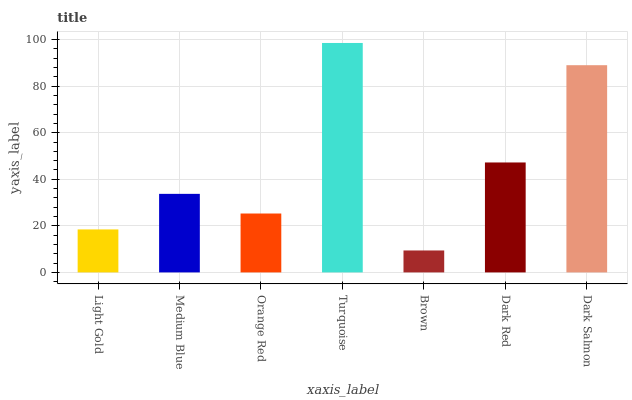Is Medium Blue the minimum?
Answer yes or no. No. Is Medium Blue the maximum?
Answer yes or no. No. Is Medium Blue greater than Light Gold?
Answer yes or no. Yes. Is Light Gold less than Medium Blue?
Answer yes or no. Yes. Is Light Gold greater than Medium Blue?
Answer yes or no. No. Is Medium Blue less than Light Gold?
Answer yes or no. No. Is Medium Blue the high median?
Answer yes or no. Yes. Is Medium Blue the low median?
Answer yes or no. Yes. Is Light Gold the high median?
Answer yes or no. No. Is Brown the low median?
Answer yes or no. No. 